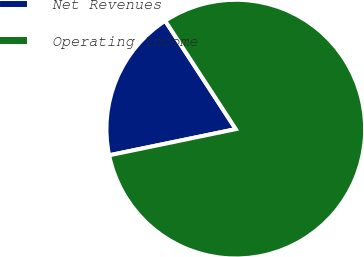Convert chart to OTSL. <chart><loc_0><loc_0><loc_500><loc_500><pie_chart><fcel>Net Revenues<fcel>Operating Income<nl><fcel>19.05%<fcel>80.95%<nl></chart> 